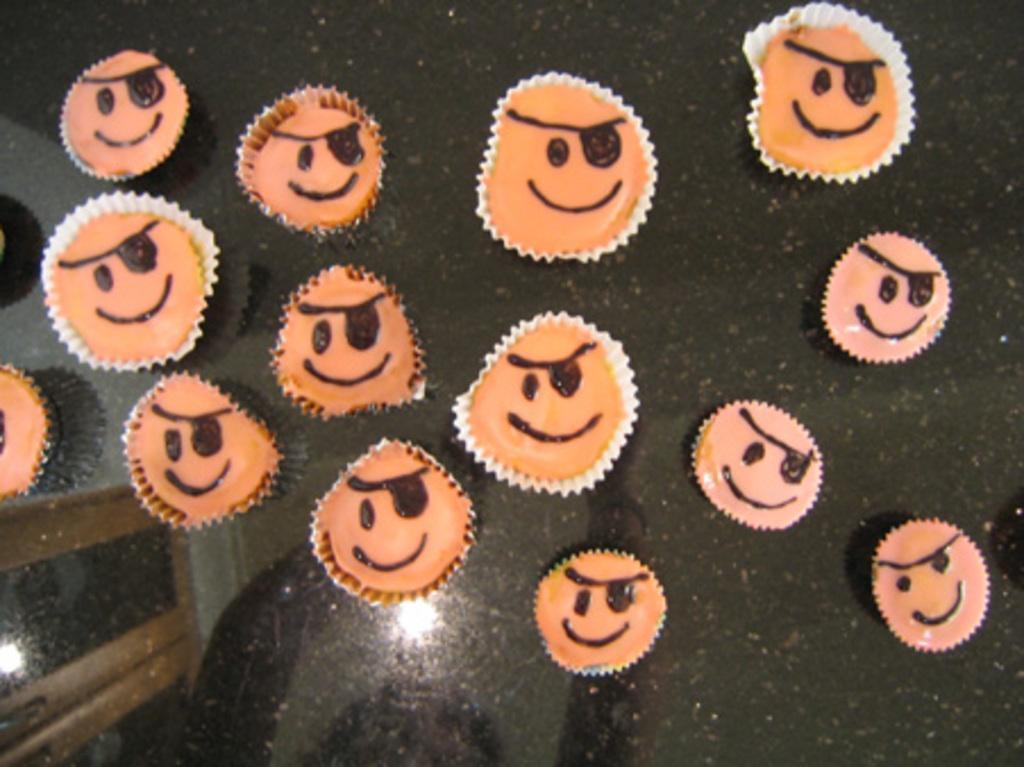Please provide a concise description of this image. In this image we can see some cupcakes which are placed on the surface. 